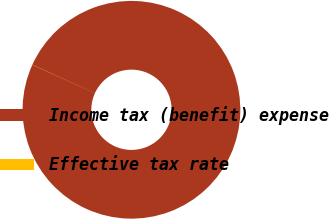<chart> <loc_0><loc_0><loc_500><loc_500><pie_chart><fcel>Income tax (benefit) expense<fcel>Effective tax rate<nl><fcel>99.98%<fcel>0.02%<nl></chart> 